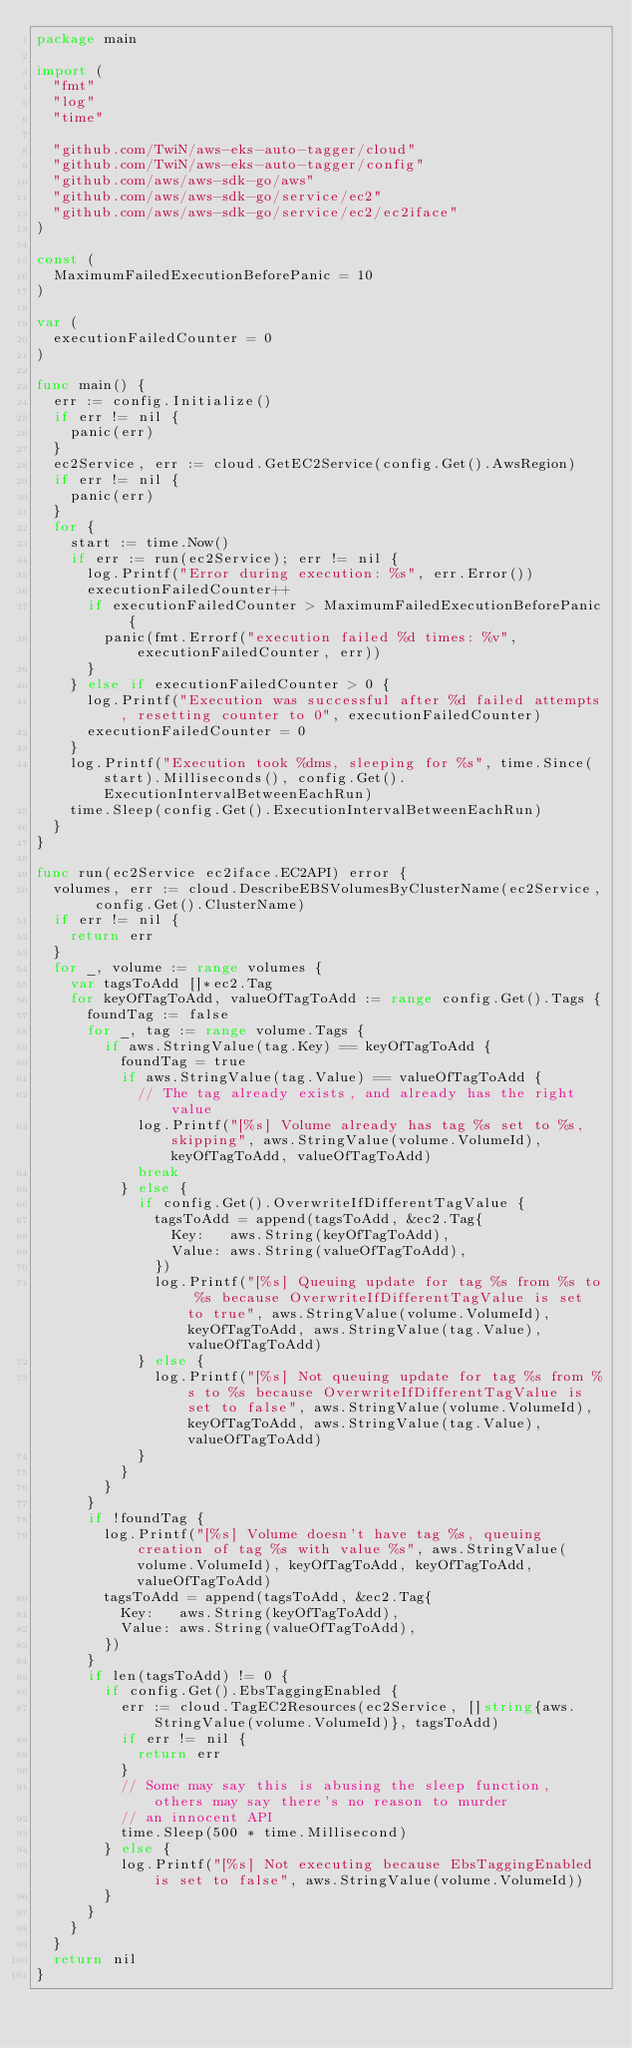<code> <loc_0><loc_0><loc_500><loc_500><_Go_>package main

import (
	"fmt"
	"log"
	"time"

	"github.com/TwiN/aws-eks-auto-tagger/cloud"
	"github.com/TwiN/aws-eks-auto-tagger/config"
	"github.com/aws/aws-sdk-go/aws"
	"github.com/aws/aws-sdk-go/service/ec2"
	"github.com/aws/aws-sdk-go/service/ec2/ec2iface"
)

const (
	MaximumFailedExecutionBeforePanic = 10
)

var (
	executionFailedCounter = 0
)

func main() {
	err := config.Initialize()
	if err != nil {
		panic(err)
	}
	ec2Service, err := cloud.GetEC2Service(config.Get().AwsRegion)
	if err != nil {
		panic(err)
	}
	for {
		start := time.Now()
		if err := run(ec2Service); err != nil {
			log.Printf("Error during execution: %s", err.Error())
			executionFailedCounter++
			if executionFailedCounter > MaximumFailedExecutionBeforePanic {
				panic(fmt.Errorf("execution failed %d times: %v", executionFailedCounter, err))
			}
		} else if executionFailedCounter > 0 {
			log.Printf("Execution was successful after %d failed attempts, resetting counter to 0", executionFailedCounter)
			executionFailedCounter = 0
		}
		log.Printf("Execution took %dms, sleeping for %s", time.Since(start).Milliseconds(), config.Get().ExecutionIntervalBetweenEachRun)
		time.Sleep(config.Get().ExecutionIntervalBetweenEachRun)
	}
}

func run(ec2Service ec2iface.EC2API) error {
	volumes, err := cloud.DescribeEBSVolumesByClusterName(ec2Service, config.Get().ClusterName)
	if err != nil {
		return err
	}
	for _, volume := range volumes {
		var tagsToAdd []*ec2.Tag
		for keyOfTagToAdd, valueOfTagToAdd := range config.Get().Tags {
			foundTag := false
			for _, tag := range volume.Tags {
				if aws.StringValue(tag.Key) == keyOfTagToAdd {
					foundTag = true
					if aws.StringValue(tag.Value) == valueOfTagToAdd {
						// The tag already exists, and already has the right value
						log.Printf("[%s] Volume already has tag %s set to %s, skipping", aws.StringValue(volume.VolumeId), keyOfTagToAdd, valueOfTagToAdd)
						break
					} else {
						if config.Get().OverwriteIfDifferentTagValue {
							tagsToAdd = append(tagsToAdd, &ec2.Tag{
								Key:   aws.String(keyOfTagToAdd),
								Value: aws.String(valueOfTagToAdd),
							})
							log.Printf("[%s] Queuing update for tag %s from %s to %s because OverwriteIfDifferentTagValue is set to true", aws.StringValue(volume.VolumeId), keyOfTagToAdd, aws.StringValue(tag.Value), valueOfTagToAdd)
						} else {
							log.Printf("[%s] Not queuing update for tag %s from %s to %s because OverwriteIfDifferentTagValue is set to false", aws.StringValue(volume.VolumeId), keyOfTagToAdd, aws.StringValue(tag.Value), valueOfTagToAdd)
						}
					}
				}
			}
			if !foundTag {
				log.Printf("[%s] Volume doesn't have tag %s, queuing creation of tag %s with value %s", aws.StringValue(volume.VolumeId), keyOfTagToAdd, keyOfTagToAdd, valueOfTagToAdd)
				tagsToAdd = append(tagsToAdd, &ec2.Tag{
					Key:   aws.String(keyOfTagToAdd),
					Value: aws.String(valueOfTagToAdd),
				})
			}
			if len(tagsToAdd) != 0 {
				if config.Get().EbsTaggingEnabled {
					err := cloud.TagEC2Resources(ec2Service, []string{aws.StringValue(volume.VolumeId)}, tagsToAdd)
					if err != nil {
						return err
					}
					// Some may say this is abusing the sleep function, others may say there's no reason to murder
					// an innocent API
					time.Sleep(500 * time.Millisecond)
				} else {
					log.Printf("[%s] Not executing because EbsTaggingEnabled is set to false", aws.StringValue(volume.VolumeId))
				}
			}
		}
	}
	return nil
}
</code> 